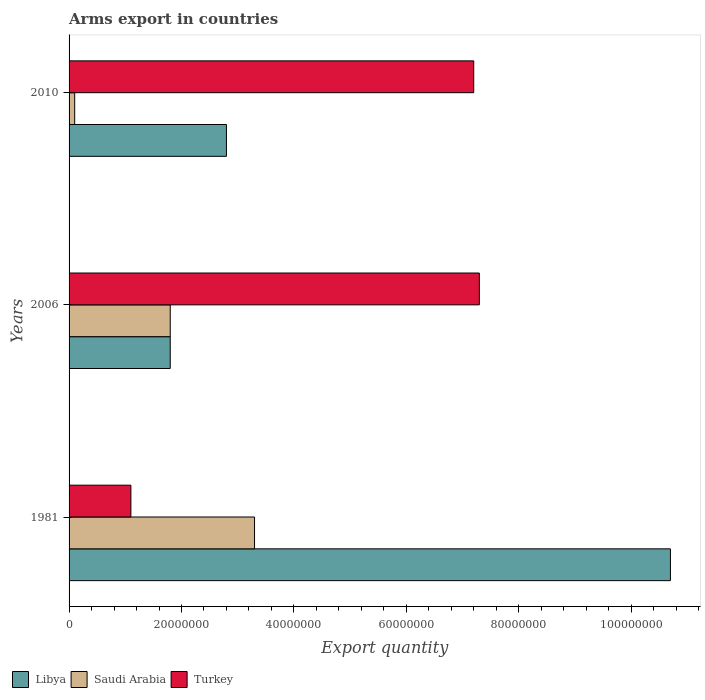Are the number of bars per tick equal to the number of legend labels?
Offer a terse response. Yes. Are the number of bars on each tick of the Y-axis equal?
Keep it short and to the point. Yes. In how many cases, is the number of bars for a given year not equal to the number of legend labels?
Your response must be concise. 0. Across all years, what is the maximum total arms export in Saudi Arabia?
Offer a very short reply. 3.30e+07. Across all years, what is the minimum total arms export in Turkey?
Ensure brevity in your answer.  1.10e+07. In which year was the total arms export in Turkey minimum?
Your answer should be compact. 1981. What is the total total arms export in Libya in the graph?
Give a very brief answer. 1.53e+08. What is the difference between the total arms export in Libya in 2006 and that in 2010?
Offer a terse response. -1.00e+07. What is the difference between the total arms export in Saudi Arabia in 1981 and the total arms export in Turkey in 2006?
Provide a succinct answer. -4.00e+07. What is the average total arms export in Saudi Arabia per year?
Provide a succinct answer. 1.73e+07. In the year 2006, what is the difference between the total arms export in Saudi Arabia and total arms export in Libya?
Ensure brevity in your answer.  0. In how many years, is the total arms export in Turkey greater than 72000000 ?
Give a very brief answer. 1. What is the difference between the highest and the second highest total arms export in Saudi Arabia?
Provide a short and direct response. 1.50e+07. What is the difference between the highest and the lowest total arms export in Saudi Arabia?
Provide a succinct answer. 3.20e+07. In how many years, is the total arms export in Saudi Arabia greater than the average total arms export in Saudi Arabia taken over all years?
Your answer should be very brief. 2. Is the sum of the total arms export in Saudi Arabia in 2006 and 2010 greater than the maximum total arms export in Turkey across all years?
Offer a very short reply. No. What does the 3rd bar from the top in 2010 represents?
Offer a terse response. Libya. What does the 1st bar from the bottom in 2010 represents?
Make the answer very short. Libya. Is it the case that in every year, the sum of the total arms export in Saudi Arabia and total arms export in Libya is greater than the total arms export in Turkey?
Keep it short and to the point. No. Are all the bars in the graph horizontal?
Your answer should be very brief. Yes. How many years are there in the graph?
Provide a succinct answer. 3. What is the difference between two consecutive major ticks on the X-axis?
Your response must be concise. 2.00e+07. Are the values on the major ticks of X-axis written in scientific E-notation?
Offer a terse response. No. Does the graph contain any zero values?
Your response must be concise. No. Where does the legend appear in the graph?
Make the answer very short. Bottom left. How many legend labels are there?
Keep it short and to the point. 3. How are the legend labels stacked?
Offer a terse response. Horizontal. What is the title of the graph?
Provide a short and direct response. Arms export in countries. Does "Georgia" appear as one of the legend labels in the graph?
Ensure brevity in your answer.  No. What is the label or title of the X-axis?
Provide a short and direct response. Export quantity. What is the Export quantity in Libya in 1981?
Make the answer very short. 1.07e+08. What is the Export quantity in Saudi Arabia in 1981?
Keep it short and to the point. 3.30e+07. What is the Export quantity of Turkey in 1981?
Ensure brevity in your answer.  1.10e+07. What is the Export quantity in Libya in 2006?
Your answer should be compact. 1.80e+07. What is the Export quantity of Saudi Arabia in 2006?
Ensure brevity in your answer.  1.80e+07. What is the Export quantity in Turkey in 2006?
Keep it short and to the point. 7.30e+07. What is the Export quantity in Libya in 2010?
Keep it short and to the point. 2.80e+07. What is the Export quantity in Saudi Arabia in 2010?
Ensure brevity in your answer.  1.00e+06. What is the Export quantity in Turkey in 2010?
Give a very brief answer. 7.20e+07. Across all years, what is the maximum Export quantity in Libya?
Your answer should be compact. 1.07e+08. Across all years, what is the maximum Export quantity in Saudi Arabia?
Your answer should be very brief. 3.30e+07. Across all years, what is the maximum Export quantity of Turkey?
Your answer should be very brief. 7.30e+07. Across all years, what is the minimum Export quantity of Libya?
Make the answer very short. 1.80e+07. Across all years, what is the minimum Export quantity of Turkey?
Provide a short and direct response. 1.10e+07. What is the total Export quantity in Libya in the graph?
Your answer should be very brief. 1.53e+08. What is the total Export quantity in Saudi Arabia in the graph?
Your response must be concise. 5.20e+07. What is the total Export quantity of Turkey in the graph?
Your response must be concise. 1.56e+08. What is the difference between the Export quantity in Libya in 1981 and that in 2006?
Give a very brief answer. 8.90e+07. What is the difference between the Export quantity in Saudi Arabia in 1981 and that in 2006?
Keep it short and to the point. 1.50e+07. What is the difference between the Export quantity in Turkey in 1981 and that in 2006?
Offer a very short reply. -6.20e+07. What is the difference between the Export quantity in Libya in 1981 and that in 2010?
Give a very brief answer. 7.90e+07. What is the difference between the Export quantity in Saudi Arabia in 1981 and that in 2010?
Your answer should be very brief. 3.20e+07. What is the difference between the Export quantity of Turkey in 1981 and that in 2010?
Provide a short and direct response. -6.10e+07. What is the difference between the Export quantity of Libya in 2006 and that in 2010?
Your answer should be compact. -1.00e+07. What is the difference between the Export quantity of Saudi Arabia in 2006 and that in 2010?
Your response must be concise. 1.70e+07. What is the difference between the Export quantity in Libya in 1981 and the Export quantity in Saudi Arabia in 2006?
Make the answer very short. 8.90e+07. What is the difference between the Export quantity of Libya in 1981 and the Export quantity of Turkey in 2006?
Your response must be concise. 3.40e+07. What is the difference between the Export quantity of Saudi Arabia in 1981 and the Export quantity of Turkey in 2006?
Ensure brevity in your answer.  -4.00e+07. What is the difference between the Export quantity of Libya in 1981 and the Export quantity of Saudi Arabia in 2010?
Your answer should be compact. 1.06e+08. What is the difference between the Export quantity in Libya in 1981 and the Export quantity in Turkey in 2010?
Keep it short and to the point. 3.50e+07. What is the difference between the Export quantity in Saudi Arabia in 1981 and the Export quantity in Turkey in 2010?
Provide a succinct answer. -3.90e+07. What is the difference between the Export quantity of Libya in 2006 and the Export quantity of Saudi Arabia in 2010?
Offer a very short reply. 1.70e+07. What is the difference between the Export quantity of Libya in 2006 and the Export quantity of Turkey in 2010?
Your answer should be compact. -5.40e+07. What is the difference between the Export quantity of Saudi Arabia in 2006 and the Export quantity of Turkey in 2010?
Provide a short and direct response. -5.40e+07. What is the average Export quantity of Libya per year?
Your response must be concise. 5.10e+07. What is the average Export quantity of Saudi Arabia per year?
Your answer should be compact. 1.73e+07. What is the average Export quantity of Turkey per year?
Your answer should be compact. 5.20e+07. In the year 1981, what is the difference between the Export quantity of Libya and Export quantity of Saudi Arabia?
Make the answer very short. 7.40e+07. In the year 1981, what is the difference between the Export quantity of Libya and Export quantity of Turkey?
Give a very brief answer. 9.60e+07. In the year 1981, what is the difference between the Export quantity in Saudi Arabia and Export quantity in Turkey?
Your answer should be very brief. 2.20e+07. In the year 2006, what is the difference between the Export quantity in Libya and Export quantity in Turkey?
Your answer should be compact. -5.50e+07. In the year 2006, what is the difference between the Export quantity of Saudi Arabia and Export quantity of Turkey?
Provide a short and direct response. -5.50e+07. In the year 2010, what is the difference between the Export quantity in Libya and Export quantity in Saudi Arabia?
Your answer should be very brief. 2.70e+07. In the year 2010, what is the difference between the Export quantity in Libya and Export quantity in Turkey?
Your response must be concise. -4.40e+07. In the year 2010, what is the difference between the Export quantity of Saudi Arabia and Export quantity of Turkey?
Offer a very short reply. -7.10e+07. What is the ratio of the Export quantity of Libya in 1981 to that in 2006?
Provide a short and direct response. 5.94. What is the ratio of the Export quantity in Saudi Arabia in 1981 to that in 2006?
Give a very brief answer. 1.83. What is the ratio of the Export quantity of Turkey in 1981 to that in 2006?
Give a very brief answer. 0.15. What is the ratio of the Export quantity in Libya in 1981 to that in 2010?
Your response must be concise. 3.82. What is the ratio of the Export quantity of Saudi Arabia in 1981 to that in 2010?
Your answer should be compact. 33. What is the ratio of the Export quantity of Turkey in 1981 to that in 2010?
Give a very brief answer. 0.15. What is the ratio of the Export quantity in Libya in 2006 to that in 2010?
Your answer should be very brief. 0.64. What is the ratio of the Export quantity of Turkey in 2006 to that in 2010?
Your answer should be very brief. 1.01. What is the difference between the highest and the second highest Export quantity of Libya?
Make the answer very short. 7.90e+07. What is the difference between the highest and the second highest Export quantity of Saudi Arabia?
Provide a succinct answer. 1.50e+07. What is the difference between the highest and the second highest Export quantity of Turkey?
Your answer should be compact. 1.00e+06. What is the difference between the highest and the lowest Export quantity in Libya?
Provide a short and direct response. 8.90e+07. What is the difference between the highest and the lowest Export quantity of Saudi Arabia?
Offer a terse response. 3.20e+07. What is the difference between the highest and the lowest Export quantity of Turkey?
Offer a terse response. 6.20e+07. 